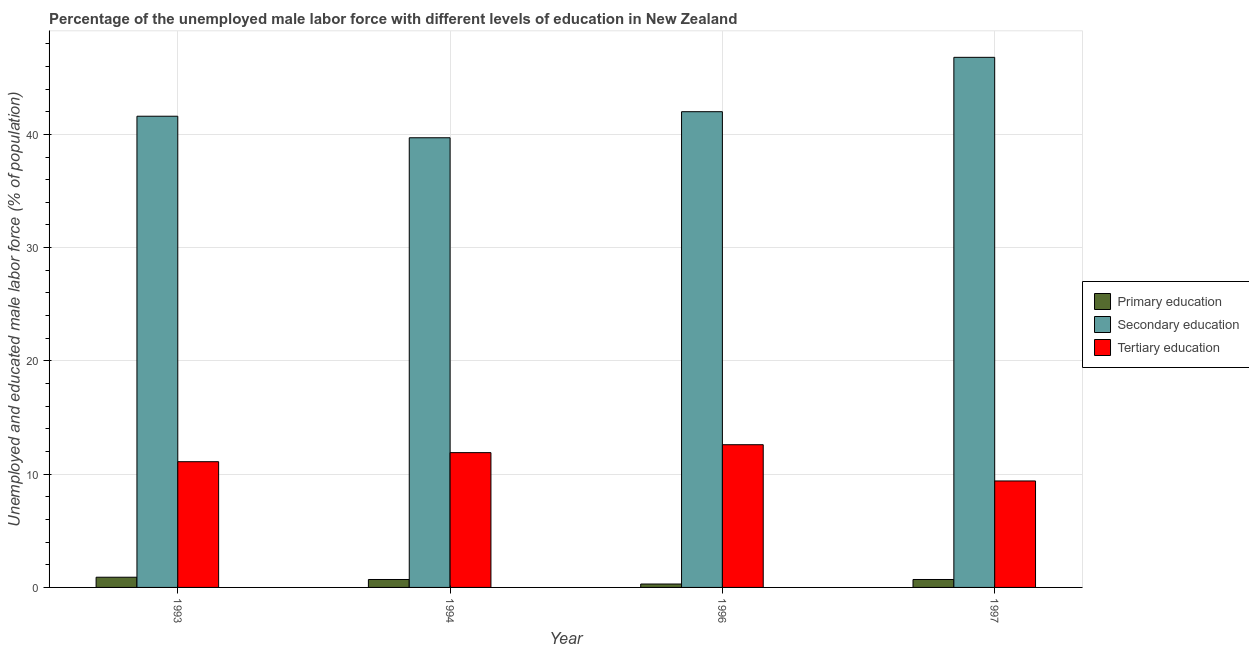Are the number of bars on each tick of the X-axis equal?
Your answer should be compact. Yes. How many bars are there on the 1st tick from the left?
Make the answer very short. 3. How many bars are there on the 1st tick from the right?
Make the answer very short. 3. What is the label of the 1st group of bars from the left?
Provide a succinct answer. 1993. What is the percentage of male labor force who received secondary education in 1993?
Your response must be concise. 41.6. Across all years, what is the maximum percentage of male labor force who received secondary education?
Ensure brevity in your answer.  46.8. Across all years, what is the minimum percentage of male labor force who received tertiary education?
Offer a very short reply. 9.4. In which year was the percentage of male labor force who received tertiary education minimum?
Make the answer very short. 1997. What is the total percentage of male labor force who received secondary education in the graph?
Make the answer very short. 170.1. What is the difference between the percentage of male labor force who received secondary education in 1994 and that in 1996?
Provide a short and direct response. -2.3. What is the difference between the percentage of male labor force who received tertiary education in 1996 and the percentage of male labor force who received secondary education in 1997?
Make the answer very short. 3.2. What is the average percentage of male labor force who received primary education per year?
Ensure brevity in your answer.  0.65. In the year 1993, what is the difference between the percentage of male labor force who received primary education and percentage of male labor force who received secondary education?
Make the answer very short. 0. What is the ratio of the percentage of male labor force who received secondary education in 1993 to that in 1997?
Your response must be concise. 0.89. What is the difference between the highest and the second highest percentage of male labor force who received primary education?
Ensure brevity in your answer.  0.2. What is the difference between the highest and the lowest percentage of male labor force who received primary education?
Offer a very short reply. 0.6. What does the 1st bar from the left in 1996 represents?
Give a very brief answer. Primary education. What does the 2nd bar from the right in 1994 represents?
Offer a very short reply. Secondary education. How many years are there in the graph?
Offer a terse response. 4. Does the graph contain grids?
Ensure brevity in your answer.  Yes. Where does the legend appear in the graph?
Provide a succinct answer. Center right. How are the legend labels stacked?
Keep it short and to the point. Vertical. What is the title of the graph?
Provide a succinct answer. Percentage of the unemployed male labor force with different levels of education in New Zealand. Does "Renewable sources" appear as one of the legend labels in the graph?
Offer a terse response. No. What is the label or title of the X-axis?
Make the answer very short. Year. What is the label or title of the Y-axis?
Give a very brief answer. Unemployed and educated male labor force (% of population). What is the Unemployed and educated male labor force (% of population) of Primary education in 1993?
Provide a succinct answer. 0.9. What is the Unemployed and educated male labor force (% of population) of Secondary education in 1993?
Keep it short and to the point. 41.6. What is the Unemployed and educated male labor force (% of population) of Tertiary education in 1993?
Offer a very short reply. 11.1. What is the Unemployed and educated male labor force (% of population) in Primary education in 1994?
Give a very brief answer. 0.7. What is the Unemployed and educated male labor force (% of population) of Secondary education in 1994?
Make the answer very short. 39.7. What is the Unemployed and educated male labor force (% of population) in Tertiary education in 1994?
Keep it short and to the point. 11.9. What is the Unemployed and educated male labor force (% of population) in Primary education in 1996?
Keep it short and to the point. 0.3. What is the Unemployed and educated male labor force (% of population) in Tertiary education in 1996?
Provide a short and direct response. 12.6. What is the Unemployed and educated male labor force (% of population) of Primary education in 1997?
Your response must be concise. 0.7. What is the Unemployed and educated male labor force (% of population) of Secondary education in 1997?
Offer a very short reply. 46.8. What is the Unemployed and educated male labor force (% of population) of Tertiary education in 1997?
Offer a terse response. 9.4. Across all years, what is the maximum Unemployed and educated male labor force (% of population) in Primary education?
Offer a very short reply. 0.9. Across all years, what is the maximum Unemployed and educated male labor force (% of population) in Secondary education?
Provide a short and direct response. 46.8. Across all years, what is the maximum Unemployed and educated male labor force (% of population) in Tertiary education?
Offer a very short reply. 12.6. Across all years, what is the minimum Unemployed and educated male labor force (% of population) of Primary education?
Provide a short and direct response. 0.3. Across all years, what is the minimum Unemployed and educated male labor force (% of population) in Secondary education?
Your response must be concise. 39.7. Across all years, what is the minimum Unemployed and educated male labor force (% of population) in Tertiary education?
Give a very brief answer. 9.4. What is the total Unemployed and educated male labor force (% of population) of Primary education in the graph?
Offer a terse response. 2.6. What is the total Unemployed and educated male labor force (% of population) in Secondary education in the graph?
Your response must be concise. 170.1. What is the difference between the Unemployed and educated male labor force (% of population) in Primary education in 1993 and that in 1994?
Your answer should be very brief. 0.2. What is the difference between the Unemployed and educated male labor force (% of population) of Tertiary education in 1993 and that in 1994?
Your answer should be compact. -0.8. What is the difference between the Unemployed and educated male labor force (% of population) in Primary education in 1993 and that in 1997?
Keep it short and to the point. 0.2. What is the difference between the Unemployed and educated male labor force (% of population) in Primary education in 1994 and that in 1996?
Ensure brevity in your answer.  0.4. What is the difference between the Unemployed and educated male labor force (% of population) in Secondary education in 1994 and that in 1996?
Offer a terse response. -2.3. What is the difference between the Unemployed and educated male labor force (% of population) of Tertiary education in 1994 and that in 1996?
Your answer should be compact. -0.7. What is the difference between the Unemployed and educated male labor force (% of population) in Primary education in 1994 and that in 1997?
Provide a short and direct response. 0. What is the difference between the Unemployed and educated male labor force (% of population) of Secondary education in 1994 and that in 1997?
Provide a short and direct response. -7.1. What is the difference between the Unemployed and educated male labor force (% of population) of Primary education in 1996 and that in 1997?
Your answer should be compact. -0.4. What is the difference between the Unemployed and educated male labor force (% of population) of Tertiary education in 1996 and that in 1997?
Give a very brief answer. 3.2. What is the difference between the Unemployed and educated male labor force (% of population) of Primary education in 1993 and the Unemployed and educated male labor force (% of population) of Secondary education in 1994?
Keep it short and to the point. -38.8. What is the difference between the Unemployed and educated male labor force (% of population) in Primary education in 1993 and the Unemployed and educated male labor force (% of population) in Tertiary education in 1994?
Provide a succinct answer. -11. What is the difference between the Unemployed and educated male labor force (% of population) in Secondary education in 1993 and the Unemployed and educated male labor force (% of population) in Tertiary education in 1994?
Your answer should be compact. 29.7. What is the difference between the Unemployed and educated male labor force (% of population) in Primary education in 1993 and the Unemployed and educated male labor force (% of population) in Secondary education in 1996?
Keep it short and to the point. -41.1. What is the difference between the Unemployed and educated male labor force (% of population) of Primary education in 1993 and the Unemployed and educated male labor force (% of population) of Tertiary education in 1996?
Your response must be concise. -11.7. What is the difference between the Unemployed and educated male labor force (% of population) of Secondary education in 1993 and the Unemployed and educated male labor force (% of population) of Tertiary education in 1996?
Your answer should be very brief. 29. What is the difference between the Unemployed and educated male labor force (% of population) of Primary education in 1993 and the Unemployed and educated male labor force (% of population) of Secondary education in 1997?
Your response must be concise. -45.9. What is the difference between the Unemployed and educated male labor force (% of population) in Secondary education in 1993 and the Unemployed and educated male labor force (% of population) in Tertiary education in 1997?
Your answer should be very brief. 32.2. What is the difference between the Unemployed and educated male labor force (% of population) of Primary education in 1994 and the Unemployed and educated male labor force (% of population) of Secondary education in 1996?
Give a very brief answer. -41.3. What is the difference between the Unemployed and educated male labor force (% of population) in Secondary education in 1994 and the Unemployed and educated male labor force (% of population) in Tertiary education in 1996?
Offer a very short reply. 27.1. What is the difference between the Unemployed and educated male labor force (% of population) in Primary education in 1994 and the Unemployed and educated male labor force (% of population) in Secondary education in 1997?
Your answer should be very brief. -46.1. What is the difference between the Unemployed and educated male labor force (% of population) of Secondary education in 1994 and the Unemployed and educated male labor force (% of population) of Tertiary education in 1997?
Make the answer very short. 30.3. What is the difference between the Unemployed and educated male labor force (% of population) of Primary education in 1996 and the Unemployed and educated male labor force (% of population) of Secondary education in 1997?
Give a very brief answer. -46.5. What is the difference between the Unemployed and educated male labor force (% of population) of Primary education in 1996 and the Unemployed and educated male labor force (% of population) of Tertiary education in 1997?
Your response must be concise. -9.1. What is the difference between the Unemployed and educated male labor force (% of population) of Secondary education in 1996 and the Unemployed and educated male labor force (% of population) of Tertiary education in 1997?
Offer a terse response. 32.6. What is the average Unemployed and educated male labor force (% of population) in Primary education per year?
Give a very brief answer. 0.65. What is the average Unemployed and educated male labor force (% of population) of Secondary education per year?
Your response must be concise. 42.52. What is the average Unemployed and educated male labor force (% of population) of Tertiary education per year?
Your answer should be compact. 11.25. In the year 1993, what is the difference between the Unemployed and educated male labor force (% of population) of Primary education and Unemployed and educated male labor force (% of population) of Secondary education?
Your answer should be compact. -40.7. In the year 1993, what is the difference between the Unemployed and educated male labor force (% of population) in Primary education and Unemployed and educated male labor force (% of population) in Tertiary education?
Your response must be concise. -10.2. In the year 1993, what is the difference between the Unemployed and educated male labor force (% of population) of Secondary education and Unemployed and educated male labor force (% of population) of Tertiary education?
Provide a succinct answer. 30.5. In the year 1994, what is the difference between the Unemployed and educated male labor force (% of population) of Primary education and Unemployed and educated male labor force (% of population) of Secondary education?
Provide a short and direct response. -39. In the year 1994, what is the difference between the Unemployed and educated male labor force (% of population) in Secondary education and Unemployed and educated male labor force (% of population) in Tertiary education?
Your answer should be very brief. 27.8. In the year 1996, what is the difference between the Unemployed and educated male labor force (% of population) of Primary education and Unemployed and educated male labor force (% of population) of Secondary education?
Your answer should be compact. -41.7. In the year 1996, what is the difference between the Unemployed and educated male labor force (% of population) in Secondary education and Unemployed and educated male labor force (% of population) in Tertiary education?
Give a very brief answer. 29.4. In the year 1997, what is the difference between the Unemployed and educated male labor force (% of population) of Primary education and Unemployed and educated male labor force (% of population) of Secondary education?
Provide a succinct answer. -46.1. In the year 1997, what is the difference between the Unemployed and educated male labor force (% of population) in Primary education and Unemployed and educated male labor force (% of population) in Tertiary education?
Make the answer very short. -8.7. In the year 1997, what is the difference between the Unemployed and educated male labor force (% of population) of Secondary education and Unemployed and educated male labor force (% of population) of Tertiary education?
Offer a very short reply. 37.4. What is the ratio of the Unemployed and educated male labor force (% of population) of Secondary education in 1993 to that in 1994?
Provide a short and direct response. 1.05. What is the ratio of the Unemployed and educated male labor force (% of population) in Tertiary education in 1993 to that in 1994?
Provide a succinct answer. 0.93. What is the ratio of the Unemployed and educated male labor force (% of population) of Tertiary education in 1993 to that in 1996?
Keep it short and to the point. 0.88. What is the ratio of the Unemployed and educated male labor force (% of population) in Secondary education in 1993 to that in 1997?
Keep it short and to the point. 0.89. What is the ratio of the Unemployed and educated male labor force (% of population) in Tertiary education in 1993 to that in 1997?
Ensure brevity in your answer.  1.18. What is the ratio of the Unemployed and educated male labor force (% of population) of Primary education in 1994 to that in 1996?
Offer a very short reply. 2.33. What is the ratio of the Unemployed and educated male labor force (% of population) in Secondary education in 1994 to that in 1996?
Provide a short and direct response. 0.95. What is the ratio of the Unemployed and educated male labor force (% of population) in Tertiary education in 1994 to that in 1996?
Your answer should be very brief. 0.94. What is the ratio of the Unemployed and educated male labor force (% of population) of Secondary education in 1994 to that in 1997?
Give a very brief answer. 0.85. What is the ratio of the Unemployed and educated male labor force (% of population) in Tertiary education in 1994 to that in 1997?
Give a very brief answer. 1.27. What is the ratio of the Unemployed and educated male labor force (% of population) in Primary education in 1996 to that in 1997?
Provide a succinct answer. 0.43. What is the ratio of the Unemployed and educated male labor force (% of population) of Secondary education in 1996 to that in 1997?
Keep it short and to the point. 0.9. What is the ratio of the Unemployed and educated male labor force (% of population) of Tertiary education in 1996 to that in 1997?
Give a very brief answer. 1.34. What is the difference between the highest and the second highest Unemployed and educated male labor force (% of population) in Primary education?
Your answer should be very brief. 0.2. What is the difference between the highest and the lowest Unemployed and educated male labor force (% of population) of Secondary education?
Your answer should be compact. 7.1. What is the difference between the highest and the lowest Unemployed and educated male labor force (% of population) in Tertiary education?
Your response must be concise. 3.2. 